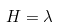Convert formula to latex. <formula><loc_0><loc_0><loc_500><loc_500>H = \lambda</formula> 